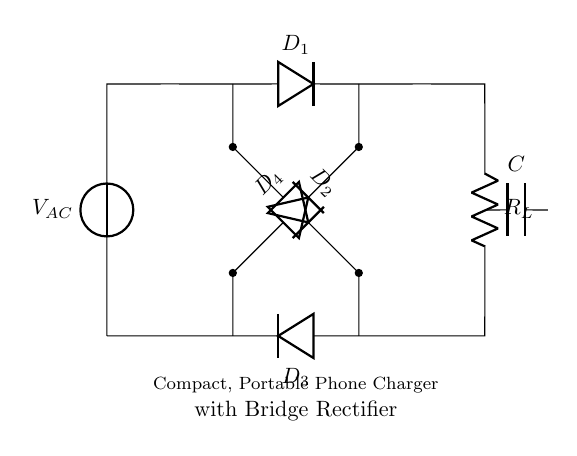What is the type of voltage source used in this circuit? The circuit uses an alternating current voltage source, indicated by the symbol labeled as V_AC at the top left.
Answer: Alternating current How many diodes are used in this bridge rectifier? The circuit diagram shows four diodes labeled as D1, D2, D3, and D4 connected in an arrangement typical for a bridge rectifier.
Answer: Four What does the capacitor in the circuit do? The capacitor, labeled as C, is used for smoothing the output voltage by filtering out the ripples produced during rectification.
Answer: Smoothing What is the role of the load resistor in the circuit? The load resistor, labeled as R_L, represents the device or component that receives the output power from the rectifier and absorbs current.
Answer: Load What is the connection type between the diodes? The diodes are connected in a bridge configuration, which allows current to flow in both directions and rectifies the AC input effectively.
Answer: Bridge configuration What type of circuit is depicted in this diagram? The diagram represents a bridge rectifier circuit, which is specifically designed for converting alternating current into direct current efficiently in a compact size.
Answer: Bridge rectifier 